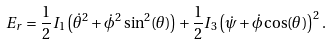Convert formula to latex. <formula><loc_0><loc_0><loc_500><loc_500>E _ { r } = { \frac { 1 } { 2 } } I _ { 1 } \left ( { \dot { \theta } } ^ { 2 } + { \dot { \phi } } ^ { 2 } \sin ^ { 2 } ( \theta ) \right ) + { \frac { 1 } { 2 } } I _ { 3 } \left ( { \dot { \psi } } + { \dot { \phi } } \cos ( \theta ) \right ) ^ { 2 } .</formula> 